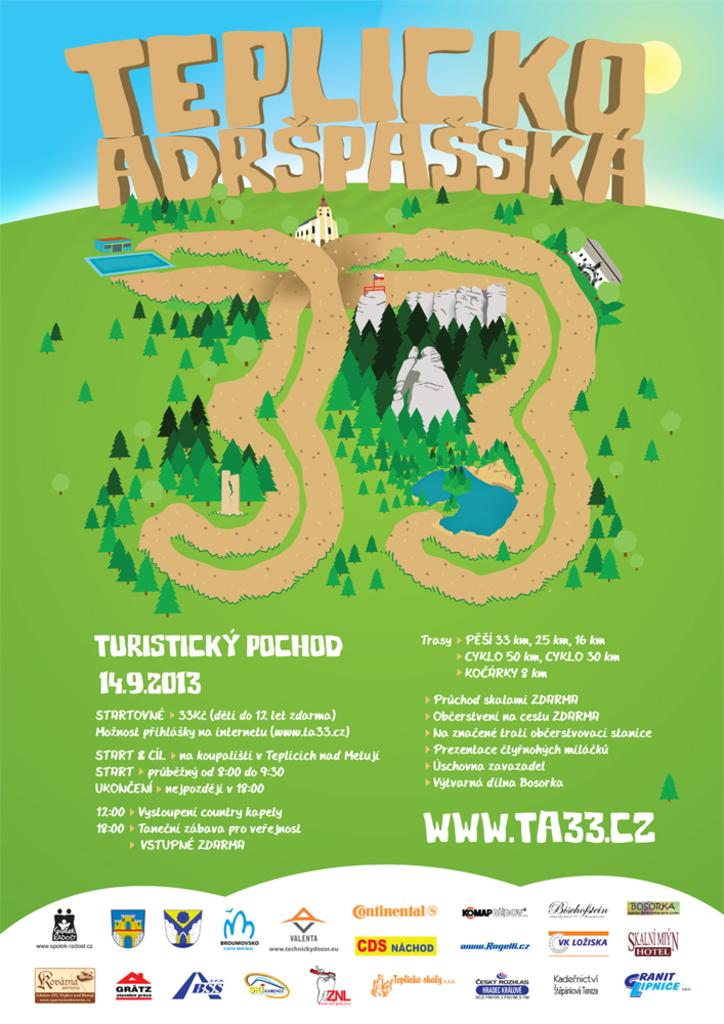What is featured in the image? There is a poster in the image. What can be found on the poster? There is text and logos on the poster. What advice does the girl give in the image? There is no girl present in the image, and therefore no advice can be given. 